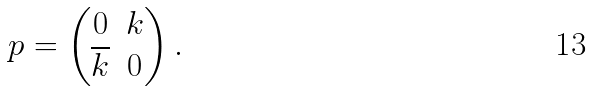<formula> <loc_0><loc_0><loc_500><loc_500>p = \left ( \begin{matrix} 0 & k \\ \overline { k } & 0 \end{matrix} \right ) .</formula> 